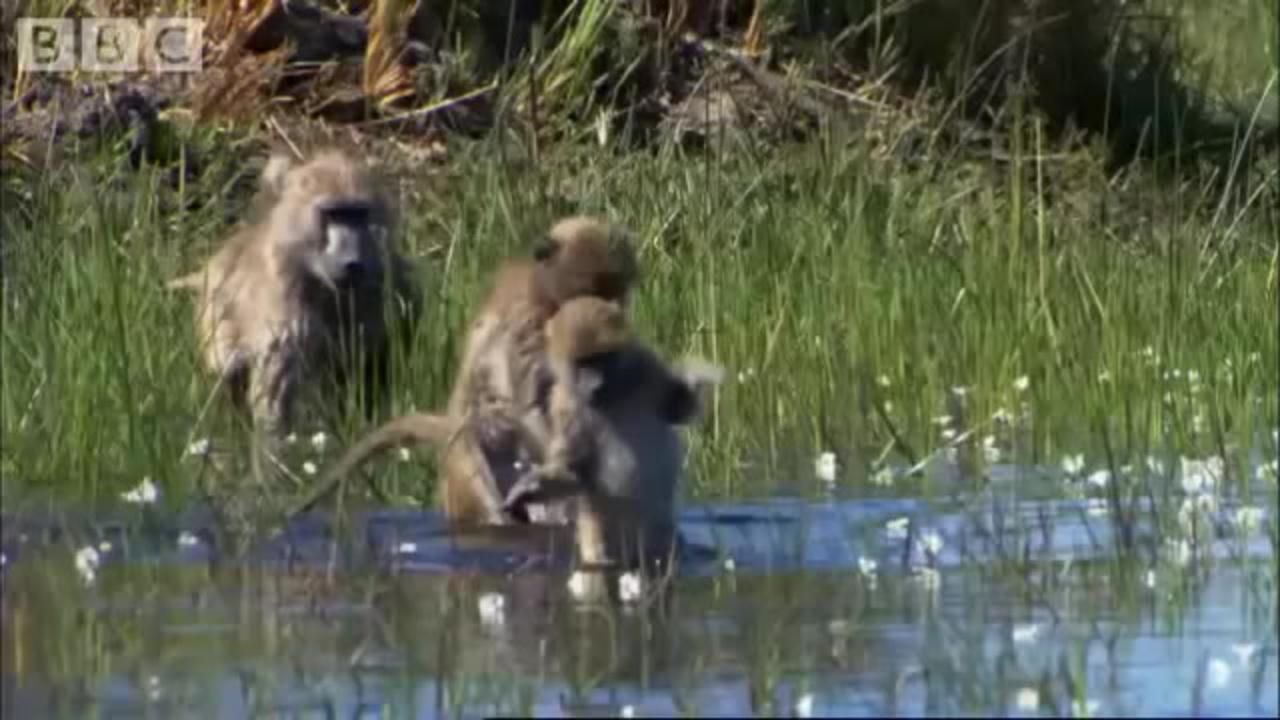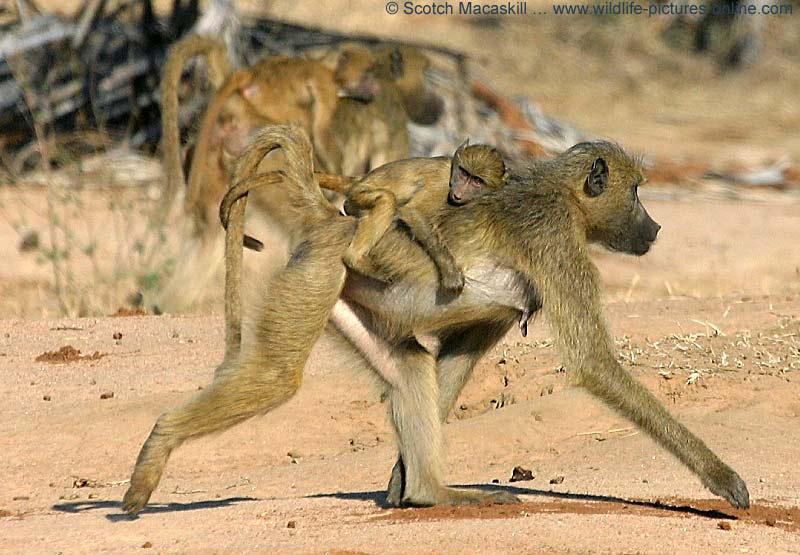The first image is the image on the left, the second image is the image on the right. Examine the images to the left and right. Is the description "One image shows baboons in the water creating splashes, and at least one of those monkeys has its tail raised." accurate? Answer yes or no. No. The first image is the image on the left, the second image is the image on the right. For the images displayed, is the sentence "An image contains exactly one primate." factually correct? Answer yes or no. No. 